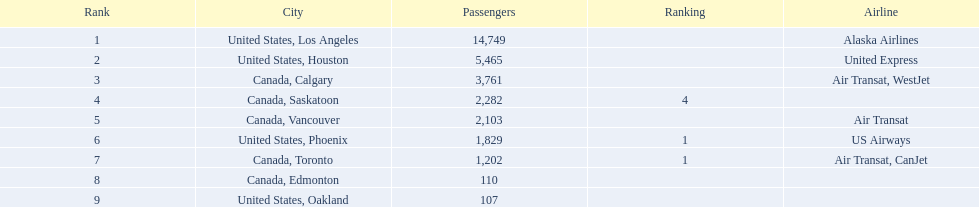Which airline is responsible for carrying the most passengers? Alaska Airlines. 